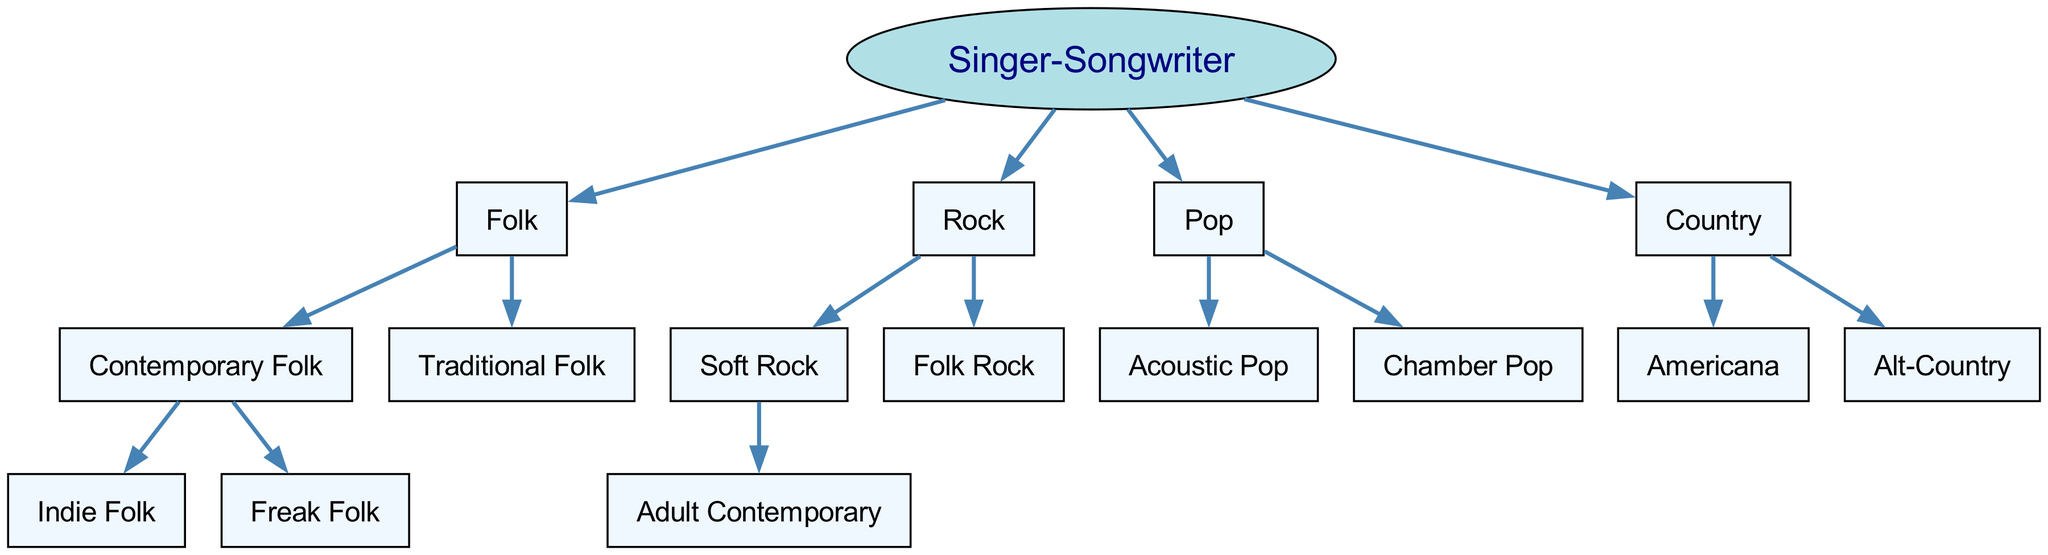What is the root genre of this family tree? The root genre is labeled at the top of the diagram; it is the starting point for all other genres and subgenres. The text directly states "Singer-Songwriter" as the root.
Answer: Singer-Songwriter How many main branches (genres) are there under the Singer-Songwriter genre? To find the number of main branches, I can count the immediate children of the "Singer-Songwriter" node in the diagram. There are four main genres displayed: Folk, Rock, Pop, and Country.
Answer: 4 Which subgenre is a child of Folk? Looking into the "Folk" category, I see there are two direct children under it, "Contemporary Folk" and "Traditional Folk." Since the question is about the subgenres under Folk, I will provide one of them, "Contemporary Folk."
Answer: Contemporary Folk What subgenre exists under Rock that has a child genre? Within the "Rock" genre, I find several children shown. The "Soft Rock" genre has a further child called "Adult Contemporary," while "Folk Rock" does not have any child subgenres. Therefore, the answer pointing to the parent with children is "Soft Rock."
Answer: Soft Rock Which genre contains the subgenre Alt-Country? To determine which genre includes "Alt-Country," I trace the node upward. "Alt-Country" is located under the "Country" genre in the diagram. Therefore, "Country" is the correct genre containing "Alt-Country."
Answer: Country How many subgenres are under Folk? I review the node labeled "Folk" and see two direct children: "Contemporary Folk" and "Traditional Folk." Counting these shows that there are two subgenres under the Folk genre.
Answer: 2 Which two main genres under the Singer-Songwriter tree directly contain the word 'Rock'? Firstly, I examine the main branches and identify that the word 'Rock' appears in both "Rock" and "Folk Rock." Hence the two main genres related to 'Rock' are "Rock" itself and "Folk Rock."
Answer: Rock, Folk Rock How many total subgenres are listed in the diagram? To find the total number of subgenres, I sum up all children across all main genres: 2 under Folk, 1 under Rock, 2 under Pop, and 2 under Country. This totals to 7 subgenres.
Answer: 7 